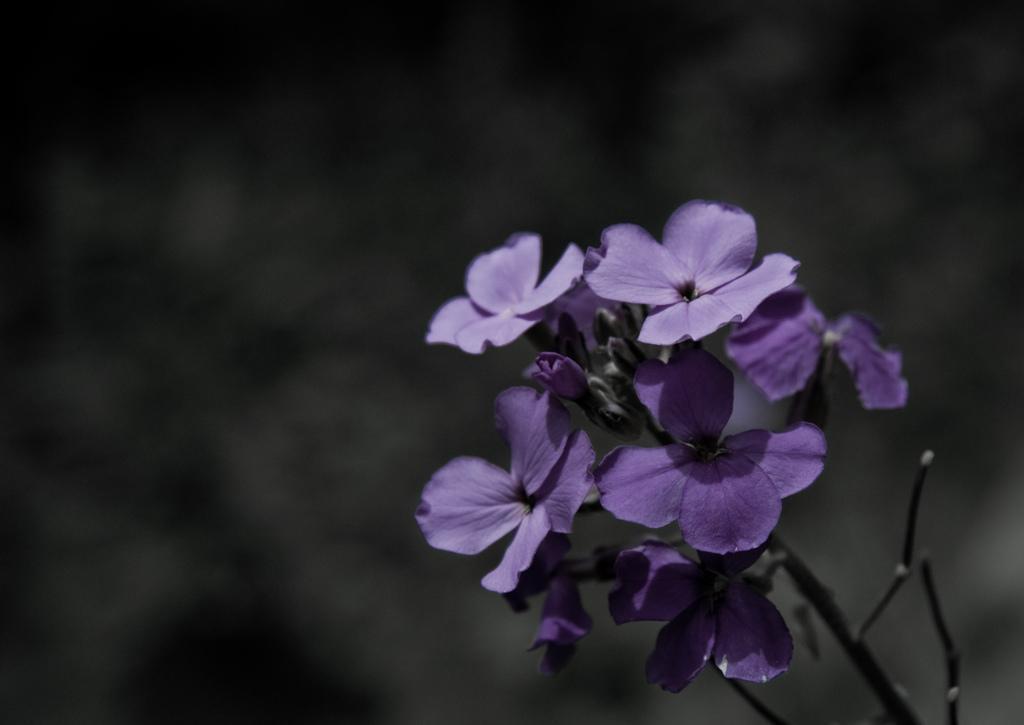How would you summarize this image in a sentence or two? In this image there is a plant having few flowers to it. Background is blurry. Flowers are in violet color. 